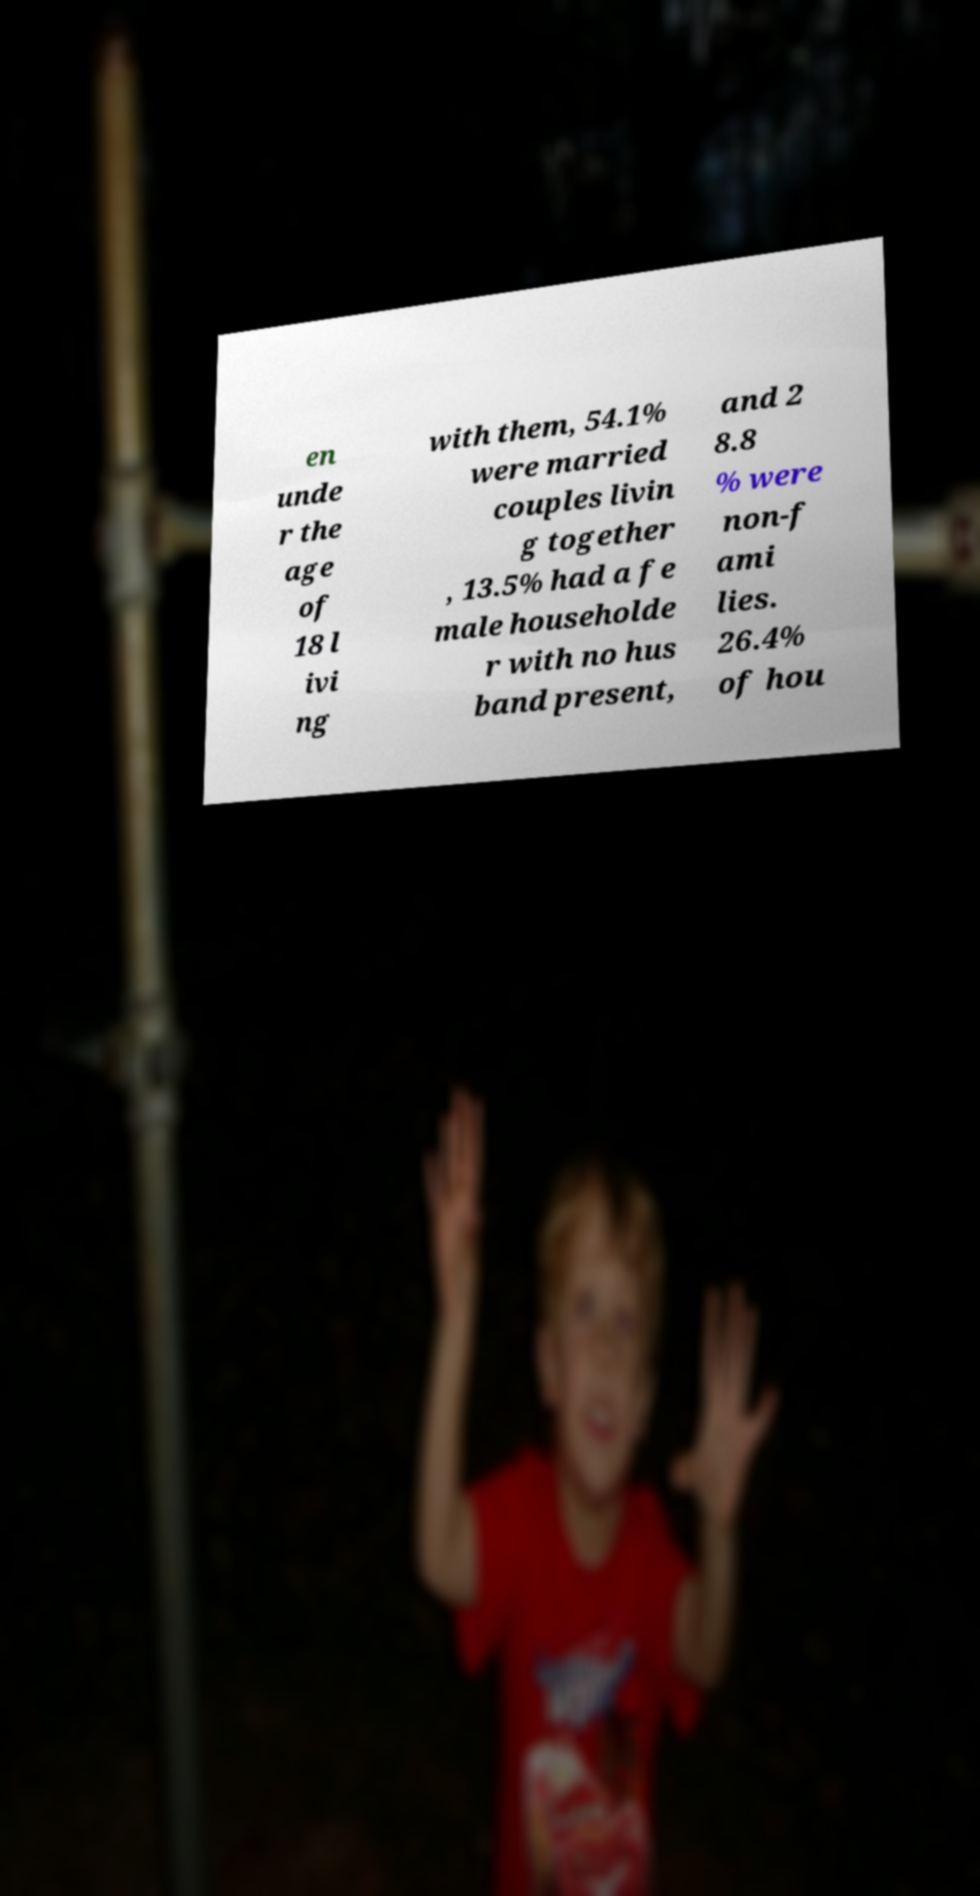Can you read and provide the text displayed in the image?This photo seems to have some interesting text. Can you extract and type it out for me? en unde r the age of 18 l ivi ng with them, 54.1% were married couples livin g together , 13.5% had a fe male householde r with no hus band present, and 2 8.8 % were non-f ami lies. 26.4% of hou 